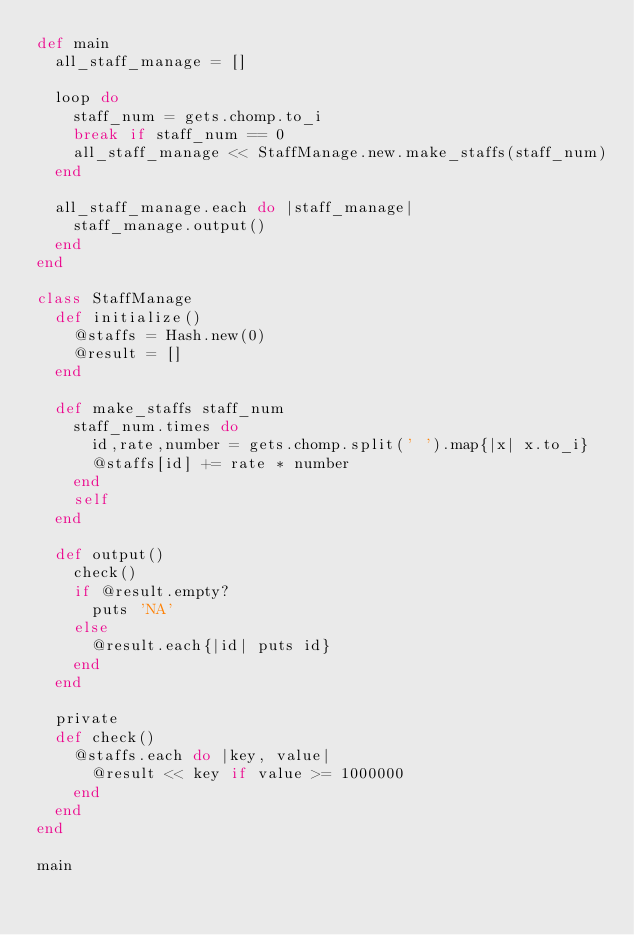Convert code to text. <code><loc_0><loc_0><loc_500><loc_500><_Ruby_>def main
  all_staff_manage = []

  loop do
    staff_num = gets.chomp.to_i
    break if staff_num == 0
    all_staff_manage << StaffManage.new.make_staffs(staff_num)
  end

  all_staff_manage.each do |staff_manage|
    staff_manage.output()
  end
end

class StaffManage
  def initialize()
    @staffs = Hash.new(0)
    @result = []
  end

  def make_staffs staff_num
    staff_num.times do
      id,rate,number = gets.chomp.split(' ').map{|x| x.to_i}
      @staffs[id] += rate * number
    end
    self
  end

  def output()
    check()
    if @result.empty?
      puts 'NA'
    else
      @result.each{|id| puts id}
    end
  end

  private
  def check()
    @staffs.each do |key, value|
      @result << key if value >= 1000000
    end
  end
end

main</code> 